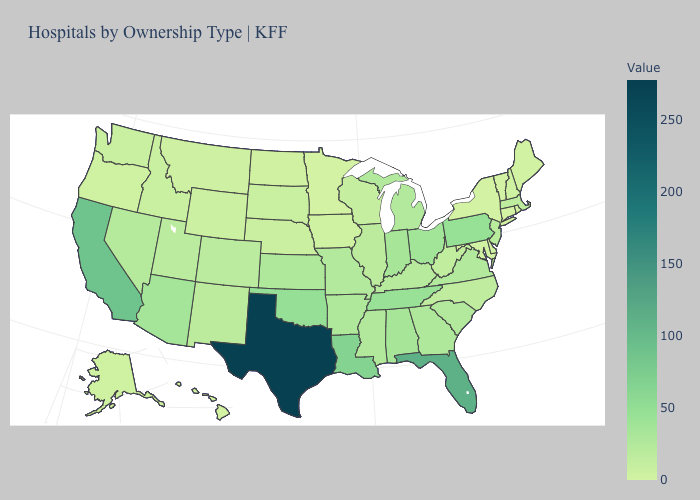Does the map have missing data?
Concise answer only. No. Does Washington have the lowest value in the West?
Answer briefly. No. Which states have the lowest value in the MidWest?
Short answer required. Minnesota. Which states have the lowest value in the USA?
Keep it brief. Connecticut, Hawaii, Minnesota, New York, Vermont. Is the legend a continuous bar?
Write a very short answer. Yes. Which states have the lowest value in the Northeast?
Quick response, please. Connecticut, New York, Vermont. 